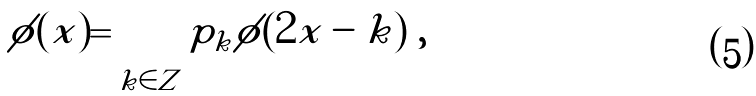<formula> <loc_0><loc_0><loc_500><loc_500>\phi ( x ) = \sum _ { k \in Z } p _ { k } \phi ( 2 x - k ) \ ,</formula> 